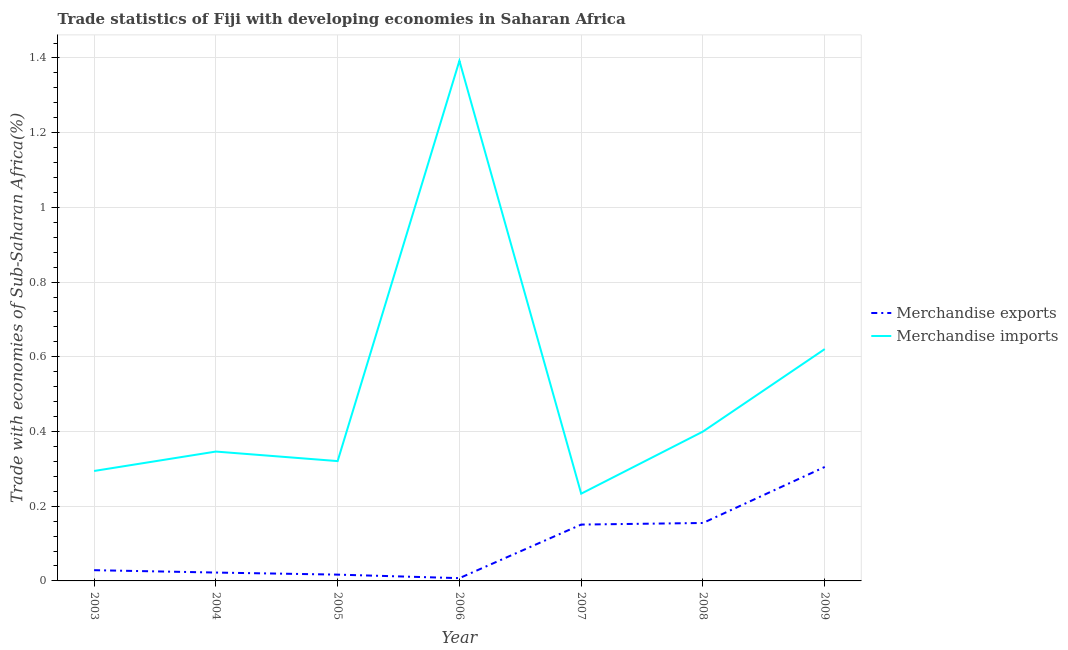How many different coloured lines are there?
Your answer should be compact. 2. Does the line corresponding to merchandise exports intersect with the line corresponding to merchandise imports?
Keep it short and to the point. No. What is the merchandise exports in 2007?
Provide a succinct answer. 0.15. Across all years, what is the maximum merchandise exports?
Offer a very short reply. 0.31. Across all years, what is the minimum merchandise imports?
Make the answer very short. 0.23. In which year was the merchandise imports maximum?
Give a very brief answer. 2006. What is the total merchandise exports in the graph?
Your answer should be very brief. 0.69. What is the difference between the merchandise exports in 2003 and that in 2008?
Offer a terse response. -0.13. What is the difference between the merchandise imports in 2007 and the merchandise exports in 2008?
Give a very brief answer. 0.08. What is the average merchandise exports per year?
Offer a terse response. 0.1. In the year 2005, what is the difference between the merchandise imports and merchandise exports?
Your answer should be very brief. 0.3. What is the ratio of the merchandise imports in 2007 to that in 2008?
Offer a terse response. 0.58. Is the merchandise imports in 2004 less than that in 2005?
Make the answer very short. No. What is the difference between the highest and the second highest merchandise imports?
Your answer should be very brief. 0.77. What is the difference between the highest and the lowest merchandise exports?
Keep it short and to the point. 0.3. In how many years, is the merchandise imports greater than the average merchandise imports taken over all years?
Provide a succinct answer. 2. Is the sum of the merchandise exports in 2003 and 2005 greater than the maximum merchandise imports across all years?
Make the answer very short. No. Is the merchandise exports strictly greater than the merchandise imports over the years?
Offer a terse response. No. Is the merchandise exports strictly less than the merchandise imports over the years?
Ensure brevity in your answer.  Yes. How many lines are there?
Make the answer very short. 2. What is the title of the graph?
Offer a very short reply. Trade statistics of Fiji with developing economies in Saharan Africa. What is the label or title of the X-axis?
Your answer should be compact. Year. What is the label or title of the Y-axis?
Provide a short and direct response. Trade with economies of Sub-Saharan Africa(%). What is the Trade with economies of Sub-Saharan Africa(%) of Merchandise exports in 2003?
Ensure brevity in your answer.  0.03. What is the Trade with economies of Sub-Saharan Africa(%) of Merchandise imports in 2003?
Make the answer very short. 0.29. What is the Trade with economies of Sub-Saharan Africa(%) of Merchandise exports in 2004?
Offer a very short reply. 0.02. What is the Trade with economies of Sub-Saharan Africa(%) of Merchandise imports in 2004?
Keep it short and to the point. 0.35. What is the Trade with economies of Sub-Saharan Africa(%) of Merchandise exports in 2005?
Make the answer very short. 0.02. What is the Trade with economies of Sub-Saharan Africa(%) of Merchandise imports in 2005?
Give a very brief answer. 0.32. What is the Trade with economies of Sub-Saharan Africa(%) of Merchandise exports in 2006?
Provide a short and direct response. 0.01. What is the Trade with economies of Sub-Saharan Africa(%) in Merchandise imports in 2006?
Provide a short and direct response. 1.39. What is the Trade with economies of Sub-Saharan Africa(%) in Merchandise exports in 2007?
Offer a terse response. 0.15. What is the Trade with economies of Sub-Saharan Africa(%) in Merchandise imports in 2007?
Ensure brevity in your answer.  0.23. What is the Trade with economies of Sub-Saharan Africa(%) in Merchandise exports in 2008?
Keep it short and to the point. 0.16. What is the Trade with economies of Sub-Saharan Africa(%) in Merchandise imports in 2008?
Offer a very short reply. 0.4. What is the Trade with economies of Sub-Saharan Africa(%) in Merchandise exports in 2009?
Give a very brief answer. 0.31. What is the Trade with economies of Sub-Saharan Africa(%) of Merchandise imports in 2009?
Provide a short and direct response. 0.62. Across all years, what is the maximum Trade with economies of Sub-Saharan Africa(%) in Merchandise exports?
Your answer should be compact. 0.31. Across all years, what is the maximum Trade with economies of Sub-Saharan Africa(%) in Merchandise imports?
Provide a short and direct response. 1.39. Across all years, what is the minimum Trade with economies of Sub-Saharan Africa(%) of Merchandise exports?
Your response must be concise. 0.01. Across all years, what is the minimum Trade with economies of Sub-Saharan Africa(%) in Merchandise imports?
Provide a succinct answer. 0.23. What is the total Trade with economies of Sub-Saharan Africa(%) of Merchandise exports in the graph?
Provide a short and direct response. 0.69. What is the total Trade with economies of Sub-Saharan Africa(%) in Merchandise imports in the graph?
Make the answer very short. 3.61. What is the difference between the Trade with economies of Sub-Saharan Africa(%) of Merchandise exports in 2003 and that in 2004?
Keep it short and to the point. 0.01. What is the difference between the Trade with economies of Sub-Saharan Africa(%) of Merchandise imports in 2003 and that in 2004?
Your answer should be very brief. -0.05. What is the difference between the Trade with economies of Sub-Saharan Africa(%) in Merchandise exports in 2003 and that in 2005?
Provide a succinct answer. 0.01. What is the difference between the Trade with economies of Sub-Saharan Africa(%) in Merchandise imports in 2003 and that in 2005?
Provide a short and direct response. -0.03. What is the difference between the Trade with economies of Sub-Saharan Africa(%) of Merchandise exports in 2003 and that in 2006?
Keep it short and to the point. 0.02. What is the difference between the Trade with economies of Sub-Saharan Africa(%) in Merchandise imports in 2003 and that in 2006?
Offer a very short reply. -1.1. What is the difference between the Trade with economies of Sub-Saharan Africa(%) in Merchandise exports in 2003 and that in 2007?
Give a very brief answer. -0.12. What is the difference between the Trade with economies of Sub-Saharan Africa(%) of Merchandise imports in 2003 and that in 2007?
Provide a short and direct response. 0.06. What is the difference between the Trade with economies of Sub-Saharan Africa(%) in Merchandise exports in 2003 and that in 2008?
Keep it short and to the point. -0.13. What is the difference between the Trade with economies of Sub-Saharan Africa(%) of Merchandise imports in 2003 and that in 2008?
Keep it short and to the point. -0.11. What is the difference between the Trade with economies of Sub-Saharan Africa(%) in Merchandise exports in 2003 and that in 2009?
Keep it short and to the point. -0.28. What is the difference between the Trade with economies of Sub-Saharan Africa(%) in Merchandise imports in 2003 and that in 2009?
Give a very brief answer. -0.33. What is the difference between the Trade with economies of Sub-Saharan Africa(%) in Merchandise exports in 2004 and that in 2005?
Your answer should be compact. 0.01. What is the difference between the Trade with economies of Sub-Saharan Africa(%) in Merchandise imports in 2004 and that in 2005?
Give a very brief answer. 0.03. What is the difference between the Trade with economies of Sub-Saharan Africa(%) in Merchandise exports in 2004 and that in 2006?
Offer a very short reply. 0.01. What is the difference between the Trade with economies of Sub-Saharan Africa(%) of Merchandise imports in 2004 and that in 2006?
Provide a succinct answer. -1.05. What is the difference between the Trade with economies of Sub-Saharan Africa(%) of Merchandise exports in 2004 and that in 2007?
Offer a terse response. -0.13. What is the difference between the Trade with economies of Sub-Saharan Africa(%) of Merchandise imports in 2004 and that in 2007?
Give a very brief answer. 0.11. What is the difference between the Trade with economies of Sub-Saharan Africa(%) of Merchandise exports in 2004 and that in 2008?
Provide a short and direct response. -0.13. What is the difference between the Trade with economies of Sub-Saharan Africa(%) of Merchandise imports in 2004 and that in 2008?
Ensure brevity in your answer.  -0.05. What is the difference between the Trade with economies of Sub-Saharan Africa(%) of Merchandise exports in 2004 and that in 2009?
Provide a succinct answer. -0.28. What is the difference between the Trade with economies of Sub-Saharan Africa(%) of Merchandise imports in 2004 and that in 2009?
Your answer should be very brief. -0.27. What is the difference between the Trade with economies of Sub-Saharan Africa(%) in Merchandise exports in 2005 and that in 2006?
Offer a very short reply. 0.01. What is the difference between the Trade with economies of Sub-Saharan Africa(%) in Merchandise imports in 2005 and that in 2006?
Offer a terse response. -1.07. What is the difference between the Trade with economies of Sub-Saharan Africa(%) in Merchandise exports in 2005 and that in 2007?
Provide a short and direct response. -0.13. What is the difference between the Trade with economies of Sub-Saharan Africa(%) of Merchandise imports in 2005 and that in 2007?
Your response must be concise. 0.09. What is the difference between the Trade with economies of Sub-Saharan Africa(%) in Merchandise exports in 2005 and that in 2008?
Keep it short and to the point. -0.14. What is the difference between the Trade with economies of Sub-Saharan Africa(%) of Merchandise imports in 2005 and that in 2008?
Ensure brevity in your answer.  -0.08. What is the difference between the Trade with economies of Sub-Saharan Africa(%) of Merchandise exports in 2005 and that in 2009?
Your answer should be compact. -0.29. What is the difference between the Trade with economies of Sub-Saharan Africa(%) in Merchandise imports in 2005 and that in 2009?
Your answer should be very brief. -0.3. What is the difference between the Trade with economies of Sub-Saharan Africa(%) of Merchandise exports in 2006 and that in 2007?
Offer a terse response. -0.14. What is the difference between the Trade with economies of Sub-Saharan Africa(%) in Merchandise imports in 2006 and that in 2007?
Ensure brevity in your answer.  1.16. What is the difference between the Trade with economies of Sub-Saharan Africa(%) of Merchandise exports in 2006 and that in 2008?
Provide a succinct answer. -0.15. What is the difference between the Trade with economies of Sub-Saharan Africa(%) in Merchandise exports in 2006 and that in 2009?
Provide a short and direct response. -0.3. What is the difference between the Trade with economies of Sub-Saharan Africa(%) of Merchandise imports in 2006 and that in 2009?
Ensure brevity in your answer.  0.77. What is the difference between the Trade with economies of Sub-Saharan Africa(%) of Merchandise exports in 2007 and that in 2008?
Offer a terse response. -0. What is the difference between the Trade with economies of Sub-Saharan Africa(%) in Merchandise imports in 2007 and that in 2008?
Give a very brief answer. -0.17. What is the difference between the Trade with economies of Sub-Saharan Africa(%) in Merchandise exports in 2007 and that in 2009?
Your answer should be compact. -0.15. What is the difference between the Trade with economies of Sub-Saharan Africa(%) of Merchandise imports in 2007 and that in 2009?
Your answer should be very brief. -0.39. What is the difference between the Trade with economies of Sub-Saharan Africa(%) in Merchandise exports in 2008 and that in 2009?
Your answer should be very brief. -0.15. What is the difference between the Trade with economies of Sub-Saharan Africa(%) of Merchandise imports in 2008 and that in 2009?
Your response must be concise. -0.22. What is the difference between the Trade with economies of Sub-Saharan Africa(%) of Merchandise exports in 2003 and the Trade with economies of Sub-Saharan Africa(%) of Merchandise imports in 2004?
Provide a short and direct response. -0.32. What is the difference between the Trade with economies of Sub-Saharan Africa(%) in Merchandise exports in 2003 and the Trade with economies of Sub-Saharan Africa(%) in Merchandise imports in 2005?
Make the answer very short. -0.29. What is the difference between the Trade with economies of Sub-Saharan Africa(%) in Merchandise exports in 2003 and the Trade with economies of Sub-Saharan Africa(%) in Merchandise imports in 2006?
Ensure brevity in your answer.  -1.36. What is the difference between the Trade with economies of Sub-Saharan Africa(%) in Merchandise exports in 2003 and the Trade with economies of Sub-Saharan Africa(%) in Merchandise imports in 2007?
Offer a very short reply. -0.2. What is the difference between the Trade with economies of Sub-Saharan Africa(%) in Merchandise exports in 2003 and the Trade with economies of Sub-Saharan Africa(%) in Merchandise imports in 2008?
Your response must be concise. -0.37. What is the difference between the Trade with economies of Sub-Saharan Africa(%) in Merchandise exports in 2003 and the Trade with economies of Sub-Saharan Africa(%) in Merchandise imports in 2009?
Provide a succinct answer. -0.59. What is the difference between the Trade with economies of Sub-Saharan Africa(%) of Merchandise exports in 2004 and the Trade with economies of Sub-Saharan Africa(%) of Merchandise imports in 2005?
Ensure brevity in your answer.  -0.3. What is the difference between the Trade with economies of Sub-Saharan Africa(%) of Merchandise exports in 2004 and the Trade with economies of Sub-Saharan Africa(%) of Merchandise imports in 2006?
Offer a terse response. -1.37. What is the difference between the Trade with economies of Sub-Saharan Africa(%) in Merchandise exports in 2004 and the Trade with economies of Sub-Saharan Africa(%) in Merchandise imports in 2007?
Give a very brief answer. -0.21. What is the difference between the Trade with economies of Sub-Saharan Africa(%) of Merchandise exports in 2004 and the Trade with economies of Sub-Saharan Africa(%) of Merchandise imports in 2008?
Your answer should be very brief. -0.38. What is the difference between the Trade with economies of Sub-Saharan Africa(%) of Merchandise exports in 2004 and the Trade with economies of Sub-Saharan Africa(%) of Merchandise imports in 2009?
Provide a short and direct response. -0.6. What is the difference between the Trade with economies of Sub-Saharan Africa(%) in Merchandise exports in 2005 and the Trade with economies of Sub-Saharan Africa(%) in Merchandise imports in 2006?
Provide a short and direct response. -1.38. What is the difference between the Trade with economies of Sub-Saharan Africa(%) of Merchandise exports in 2005 and the Trade with economies of Sub-Saharan Africa(%) of Merchandise imports in 2007?
Your answer should be very brief. -0.22. What is the difference between the Trade with economies of Sub-Saharan Africa(%) in Merchandise exports in 2005 and the Trade with economies of Sub-Saharan Africa(%) in Merchandise imports in 2008?
Keep it short and to the point. -0.38. What is the difference between the Trade with economies of Sub-Saharan Africa(%) of Merchandise exports in 2005 and the Trade with economies of Sub-Saharan Africa(%) of Merchandise imports in 2009?
Provide a succinct answer. -0.6. What is the difference between the Trade with economies of Sub-Saharan Africa(%) of Merchandise exports in 2006 and the Trade with economies of Sub-Saharan Africa(%) of Merchandise imports in 2007?
Give a very brief answer. -0.23. What is the difference between the Trade with economies of Sub-Saharan Africa(%) in Merchandise exports in 2006 and the Trade with economies of Sub-Saharan Africa(%) in Merchandise imports in 2008?
Your answer should be compact. -0.39. What is the difference between the Trade with economies of Sub-Saharan Africa(%) in Merchandise exports in 2006 and the Trade with economies of Sub-Saharan Africa(%) in Merchandise imports in 2009?
Your response must be concise. -0.61. What is the difference between the Trade with economies of Sub-Saharan Africa(%) of Merchandise exports in 2007 and the Trade with economies of Sub-Saharan Africa(%) of Merchandise imports in 2008?
Your answer should be very brief. -0.25. What is the difference between the Trade with economies of Sub-Saharan Africa(%) in Merchandise exports in 2007 and the Trade with economies of Sub-Saharan Africa(%) in Merchandise imports in 2009?
Your answer should be compact. -0.47. What is the difference between the Trade with economies of Sub-Saharan Africa(%) in Merchandise exports in 2008 and the Trade with economies of Sub-Saharan Africa(%) in Merchandise imports in 2009?
Give a very brief answer. -0.47. What is the average Trade with economies of Sub-Saharan Africa(%) of Merchandise exports per year?
Provide a succinct answer. 0.1. What is the average Trade with economies of Sub-Saharan Africa(%) of Merchandise imports per year?
Ensure brevity in your answer.  0.52. In the year 2003, what is the difference between the Trade with economies of Sub-Saharan Africa(%) of Merchandise exports and Trade with economies of Sub-Saharan Africa(%) of Merchandise imports?
Your response must be concise. -0.27. In the year 2004, what is the difference between the Trade with economies of Sub-Saharan Africa(%) of Merchandise exports and Trade with economies of Sub-Saharan Africa(%) of Merchandise imports?
Make the answer very short. -0.32. In the year 2005, what is the difference between the Trade with economies of Sub-Saharan Africa(%) in Merchandise exports and Trade with economies of Sub-Saharan Africa(%) in Merchandise imports?
Offer a terse response. -0.3. In the year 2006, what is the difference between the Trade with economies of Sub-Saharan Africa(%) in Merchandise exports and Trade with economies of Sub-Saharan Africa(%) in Merchandise imports?
Provide a succinct answer. -1.39. In the year 2007, what is the difference between the Trade with economies of Sub-Saharan Africa(%) of Merchandise exports and Trade with economies of Sub-Saharan Africa(%) of Merchandise imports?
Offer a very short reply. -0.08. In the year 2008, what is the difference between the Trade with economies of Sub-Saharan Africa(%) in Merchandise exports and Trade with economies of Sub-Saharan Africa(%) in Merchandise imports?
Make the answer very short. -0.24. In the year 2009, what is the difference between the Trade with economies of Sub-Saharan Africa(%) in Merchandise exports and Trade with economies of Sub-Saharan Africa(%) in Merchandise imports?
Your answer should be very brief. -0.32. What is the ratio of the Trade with economies of Sub-Saharan Africa(%) in Merchandise exports in 2003 to that in 2004?
Ensure brevity in your answer.  1.28. What is the ratio of the Trade with economies of Sub-Saharan Africa(%) of Merchandise imports in 2003 to that in 2004?
Your response must be concise. 0.85. What is the ratio of the Trade with economies of Sub-Saharan Africa(%) in Merchandise exports in 2003 to that in 2005?
Make the answer very short. 1.71. What is the ratio of the Trade with economies of Sub-Saharan Africa(%) of Merchandise imports in 2003 to that in 2005?
Your answer should be compact. 0.92. What is the ratio of the Trade with economies of Sub-Saharan Africa(%) in Merchandise exports in 2003 to that in 2006?
Offer a very short reply. 3.89. What is the ratio of the Trade with economies of Sub-Saharan Africa(%) of Merchandise imports in 2003 to that in 2006?
Keep it short and to the point. 0.21. What is the ratio of the Trade with economies of Sub-Saharan Africa(%) of Merchandise exports in 2003 to that in 2007?
Your response must be concise. 0.19. What is the ratio of the Trade with economies of Sub-Saharan Africa(%) in Merchandise imports in 2003 to that in 2007?
Your response must be concise. 1.26. What is the ratio of the Trade with economies of Sub-Saharan Africa(%) in Merchandise exports in 2003 to that in 2008?
Offer a terse response. 0.19. What is the ratio of the Trade with economies of Sub-Saharan Africa(%) of Merchandise imports in 2003 to that in 2008?
Offer a terse response. 0.74. What is the ratio of the Trade with economies of Sub-Saharan Africa(%) of Merchandise exports in 2003 to that in 2009?
Provide a short and direct response. 0.09. What is the ratio of the Trade with economies of Sub-Saharan Africa(%) of Merchandise imports in 2003 to that in 2009?
Your answer should be very brief. 0.47. What is the ratio of the Trade with economies of Sub-Saharan Africa(%) of Merchandise exports in 2004 to that in 2005?
Ensure brevity in your answer.  1.33. What is the ratio of the Trade with economies of Sub-Saharan Africa(%) in Merchandise imports in 2004 to that in 2005?
Your response must be concise. 1.08. What is the ratio of the Trade with economies of Sub-Saharan Africa(%) in Merchandise exports in 2004 to that in 2006?
Provide a succinct answer. 3.03. What is the ratio of the Trade with economies of Sub-Saharan Africa(%) in Merchandise imports in 2004 to that in 2006?
Make the answer very short. 0.25. What is the ratio of the Trade with economies of Sub-Saharan Africa(%) in Merchandise exports in 2004 to that in 2007?
Give a very brief answer. 0.15. What is the ratio of the Trade with economies of Sub-Saharan Africa(%) in Merchandise imports in 2004 to that in 2007?
Ensure brevity in your answer.  1.48. What is the ratio of the Trade with economies of Sub-Saharan Africa(%) of Merchandise exports in 2004 to that in 2008?
Your answer should be compact. 0.14. What is the ratio of the Trade with economies of Sub-Saharan Africa(%) of Merchandise imports in 2004 to that in 2008?
Keep it short and to the point. 0.87. What is the ratio of the Trade with economies of Sub-Saharan Africa(%) in Merchandise exports in 2004 to that in 2009?
Provide a succinct answer. 0.07. What is the ratio of the Trade with economies of Sub-Saharan Africa(%) in Merchandise imports in 2004 to that in 2009?
Provide a short and direct response. 0.56. What is the ratio of the Trade with economies of Sub-Saharan Africa(%) in Merchandise exports in 2005 to that in 2006?
Offer a very short reply. 2.28. What is the ratio of the Trade with economies of Sub-Saharan Africa(%) of Merchandise imports in 2005 to that in 2006?
Ensure brevity in your answer.  0.23. What is the ratio of the Trade with economies of Sub-Saharan Africa(%) in Merchandise exports in 2005 to that in 2007?
Your answer should be compact. 0.11. What is the ratio of the Trade with economies of Sub-Saharan Africa(%) of Merchandise imports in 2005 to that in 2007?
Provide a succinct answer. 1.37. What is the ratio of the Trade with economies of Sub-Saharan Africa(%) in Merchandise exports in 2005 to that in 2008?
Your answer should be very brief. 0.11. What is the ratio of the Trade with economies of Sub-Saharan Africa(%) in Merchandise imports in 2005 to that in 2008?
Offer a terse response. 0.8. What is the ratio of the Trade with economies of Sub-Saharan Africa(%) in Merchandise exports in 2005 to that in 2009?
Provide a short and direct response. 0.06. What is the ratio of the Trade with economies of Sub-Saharan Africa(%) in Merchandise imports in 2005 to that in 2009?
Provide a succinct answer. 0.52. What is the ratio of the Trade with economies of Sub-Saharan Africa(%) of Merchandise exports in 2006 to that in 2007?
Make the answer very short. 0.05. What is the ratio of the Trade with economies of Sub-Saharan Africa(%) of Merchandise imports in 2006 to that in 2007?
Ensure brevity in your answer.  5.96. What is the ratio of the Trade with economies of Sub-Saharan Africa(%) in Merchandise exports in 2006 to that in 2008?
Your response must be concise. 0.05. What is the ratio of the Trade with economies of Sub-Saharan Africa(%) in Merchandise imports in 2006 to that in 2008?
Ensure brevity in your answer.  3.48. What is the ratio of the Trade with economies of Sub-Saharan Africa(%) in Merchandise exports in 2006 to that in 2009?
Offer a very short reply. 0.02. What is the ratio of the Trade with economies of Sub-Saharan Africa(%) in Merchandise imports in 2006 to that in 2009?
Make the answer very short. 2.24. What is the ratio of the Trade with economies of Sub-Saharan Africa(%) in Merchandise exports in 2007 to that in 2008?
Give a very brief answer. 0.97. What is the ratio of the Trade with economies of Sub-Saharan Africa(%) in Merchandise imports in 2007 to that in 2008?
Provide a short and direct response. 0.58. What is the ratio of the Trade with economies of Sub-Saharan Africa(%) of Merchandise exports in 2007 to that in 2009?
Ensure brevity in your answer.  0.49. What is the ratio of the Trade with economies of Sub-Saharan Africa(%) of Merchandise imports in 2007 to that in 2009?
Your answer should be compact. 0.38. What is the ratio of the Trade with economies of Sub-Saharan Africa(%) of Merchandise exports in 2008 to that in 2009?
Your response must be concise. 0.51. What is the ratio of the Trade with economies of Sub-Saharan Africa(%) of Merchandise imports in 2008 to that in 2009?
Ensure brevity in your answer.  0.64. What is the difference between the highest and the second highest Trade with economies of Sub-Saharan Africa(%) in Merchandise exports?
Your response must be concise. 0.15. What is the difference between the highest and the second highest Trade with economies of Sub-Saharan Africa(%) in Merchandise imports?
Ensure brevity in your answer.  0.77. What is the difference between the highest and the lowest Trade with economies of Sub-Saharan Africa(%) in Merchandise exports?
Give a very brief answer. 0.3. What is the difference between the highest and the lowest Trade with economies of Sub-Saharan Africa(%) in Merchandise imports?
Keep it short and to the point. 1.16. 